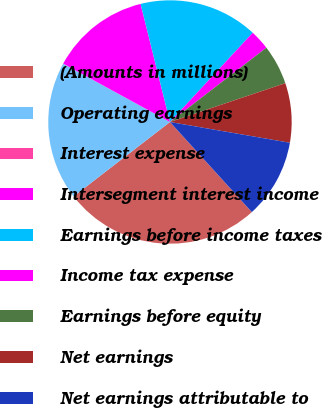Convert chart. <chart><loc_0><loc_0><loc_500><loc_500><pie_chart><fcel>(Amounts in millions)<fcel>Operating earnings<fcel>Interest expense<fcel>Intersegment interest income<fcel>Earnings before income taxes<fcel>Income tax expense<fcel>Earnings before equity<fcel>Net earnings<fcel>Net earnings attributable to<nl><fcel>26.28%<fcel>18.41%<fcel>0.02%<fcel>13.15%<fcel>15.78%<fcel>2.65%<fcel>5.28%<fcel>7.9%<fcel>10.53%<nl></chart> 